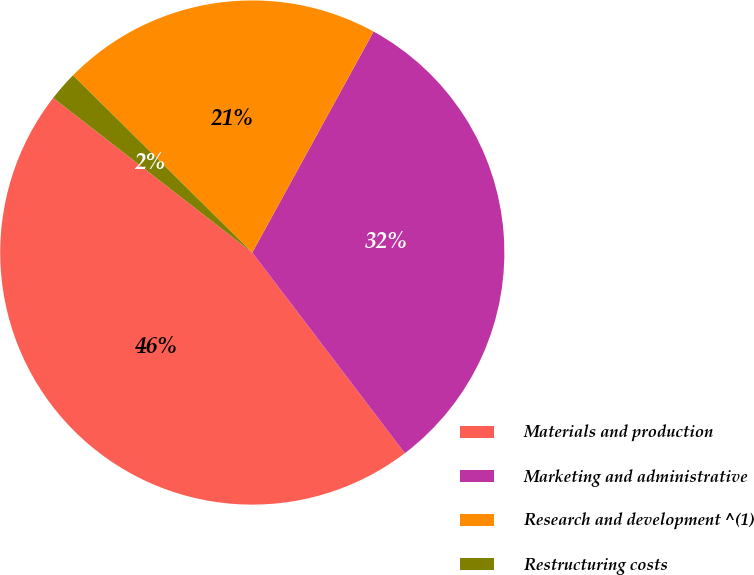<chart> <loc_0><loc_0><loc_500><loc_500><pie_chart><fcel>Materials and production<fcel>Marketing and administrative<fcel>Research and development ^(1)<fcel>Restructuring costs<nl><fcel>45.85%<fcel>31.66%<fcel>20.58%<fcel>1.9%<nl></chart> 